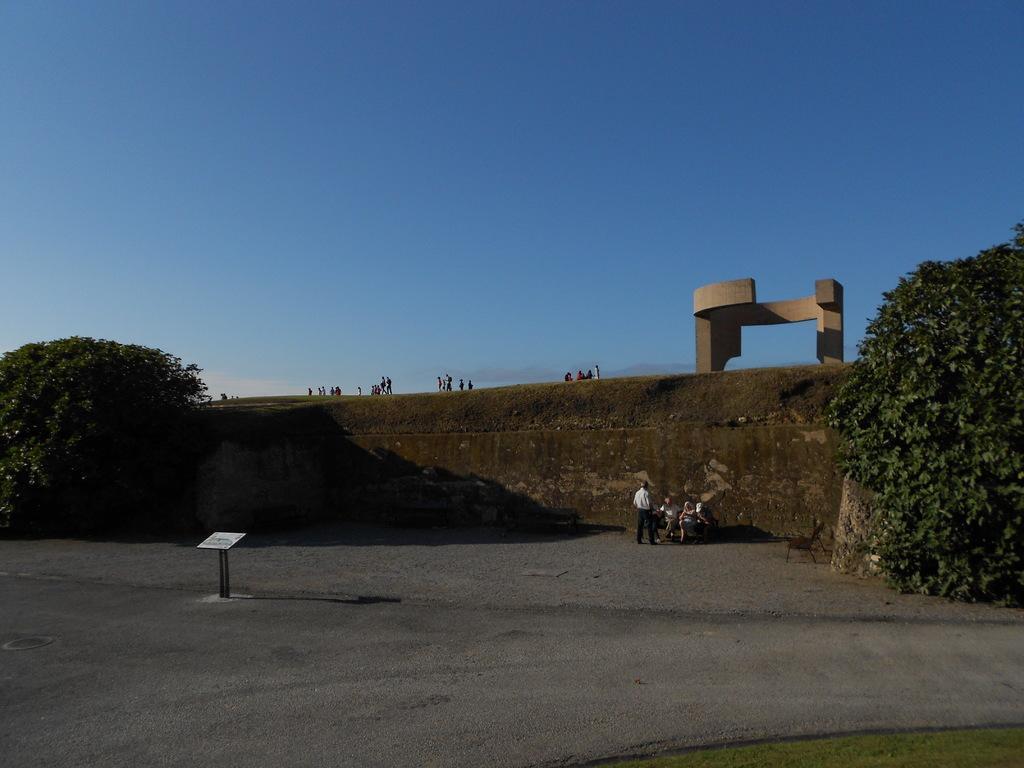In one or two sentences, can you explain what this image depicts? In the picture I can see two persons are sitting on the wooden benches and a person standing here. Here we can see trees on either side of the image, we can see many people are standing on the hill and a different architecture and the blue color sky in the background. 